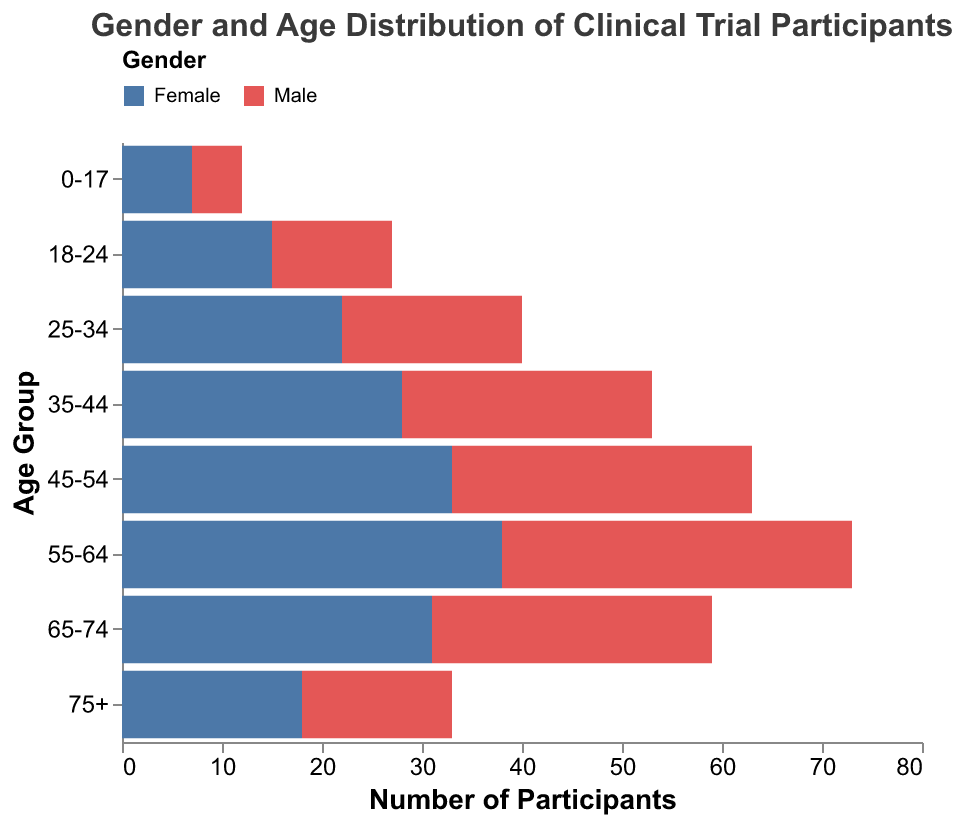Which age group has the highest number of male participants? The age group with the highest number of male participants can be found by looking for the bar that extends the furthest to the left in the Male sections. The age group 55-64 has the furthest left bar, indicating -35 male participants.
Answer: 55-64 What's the difference in the number of participants between males and females in the 35-44 age group? To find the difference, subtract the number of male participants from the number of female participants in the 35-44 age group. The values are 28 (female) and -25 (male). So, 28 - (-25) = 28 + 25 = 53.
Answer: 53 Which gender has more participants in the 65-74 age group? Compare the absolute values of male and female participants in the 65-74 age group. There are 28 male participants and 31 female participants. Since 31 is greater than 28, females have more participants.
Answer: Female What is the total number of participants in the age group 75+? Add the absolute values of male and female participants in the 75+ age group. This is 15 (male) + 18 (female) = 33.
Answer: 33 What's the overall difference in the number of participants between males and females across all age groups? Sum the absolute values of male participants and female participants separately. Male: 5+12+18+25+30+35+28+15 = 168. Female: 7+15+22+28+33+38+31+18 = 192. Then, subtract the total male participants from the total female participants to find the overall difference: 192 - 168 = 24.
Answer: 24 Which age group has the least disparity between male and female participants? Calculate the absolute difference between male and female participants for each age group and find the smallest value: The disparities are 2 (0-17), 3 (18-24), 4 (25-34), 3 (35-44), 3 (45-54), 3 (55-64), 3 (65-74), 3 (75+). The age group 0-17 has the smallest disparity.
Answer: 0-17 Which age group has the highest total number of participants? Sum the absolute values of male and female participants for each age group and find the highest total. The highest total is in the 55-64 age group: 35 (male) + 38 (female) = 73 participants.
Answer: 55-64 Which gender has more participants overall? Sum the total number of male and female participants across all age groups. Males: 5+12+18+25+30+35+28+15 = 168. Females: 7+15+22+28+33+38+31+18 = 192. Females have more participants.
Answer: Female What is the most common age group among female participants? Look for the age group with the highest number of female participants. The age group 55-64 has the highest number with 38 female participants.
Answer: 55-64 What's the proportion of male participants in the 18-24 age group relative to the total number of participants in that age group? Add the absolute values of male and female participants in the 18-24 age group: 12 (male) + 15 (female) = 27. The proportion of male participants is 12 / 27.
Answer: 12/27 